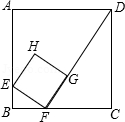What would be an optimal way to divide square ABCD into four smaller squares of equal size? An optimal division of square ABCD into four smaller, equal squares would involve drawing two lines: one horizontal and one vertical, each bisecting the square. These lines would intersect at the center point of ABCD, creating four smaller squares, each with area exactly one-fourth that of ABCD. This arrangement maximizes efficiency and symmetry, dividing the area uniformly. 